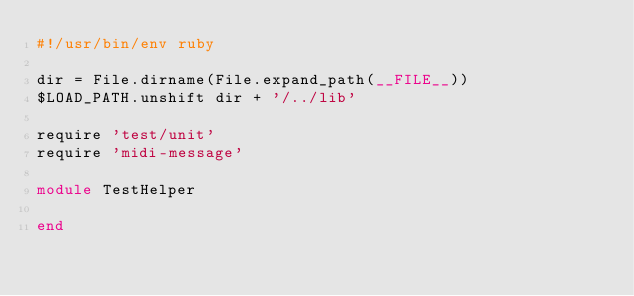Convert code to text. <code><loc_0><loc_0><loc_500><loc_500><_Ruby_>#!/usr/bin/env ruby

dir = File.dirname(File.expand_path(__FILE__))
$LOAD_PATH.unshift dir + '/../lib'

require 'test/unit'
require 'midi-message'

module TestHelper
  
end</code> 